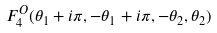<formula> <loc_0><loc_0><loc_500><loc_500>F _ { 4 } ^ { O } ( \theta _ { 1 } + i \pi , - \theta _ { 1 } + i \pi , - \theta _ { 2 } , \theta _ { 2 } )</formula> 